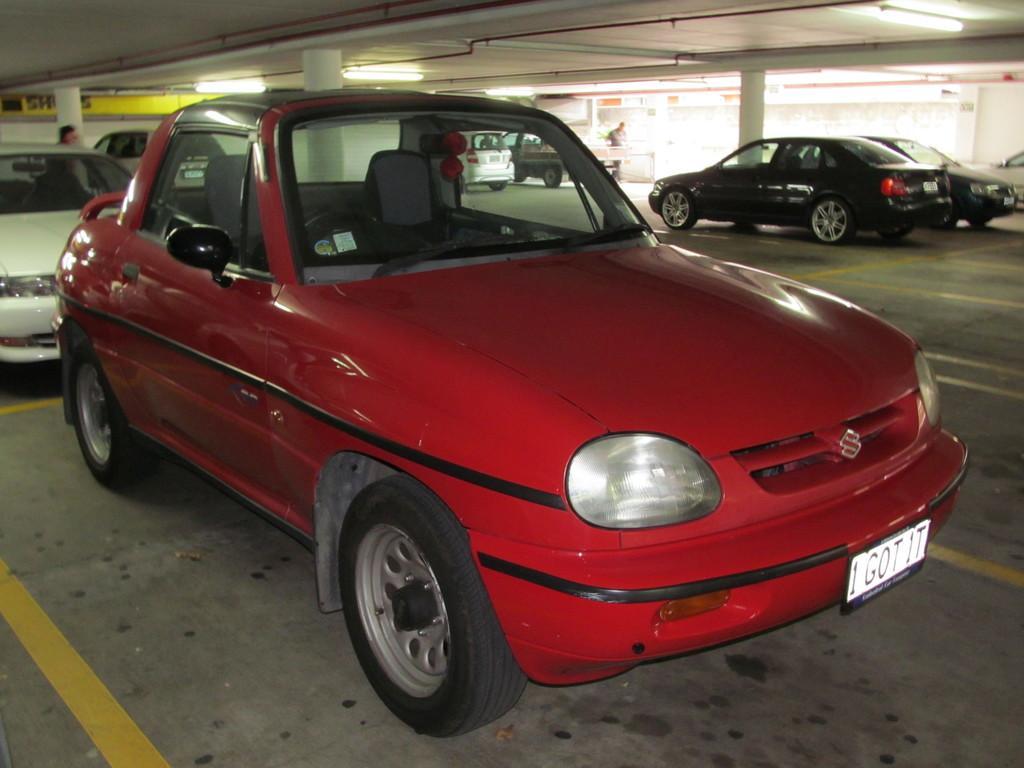Could you give a brief overview of what you see in this image? In this image on the foreground there is a red car and there are some other cars on the right side. 